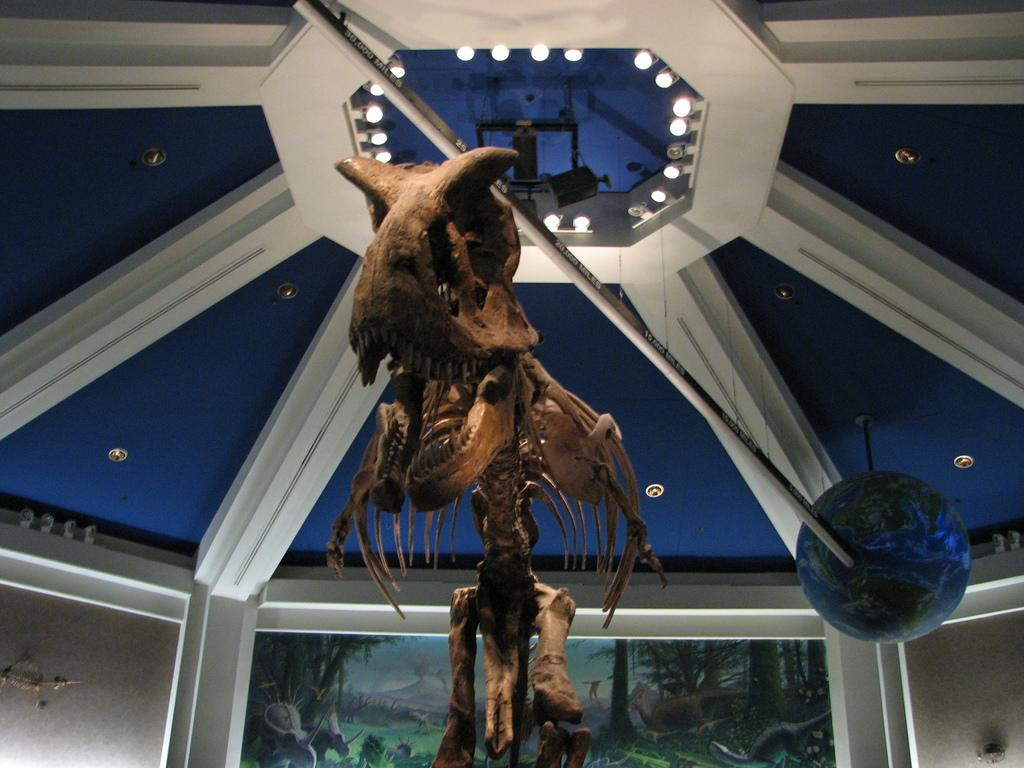What is the main subject of the image? There is a skeleton in the image. What can be seen on the wall in the image? There is a painting on the wall in the image. What is providing illumination in the image? There are lights visible in the image. What type of iron is being used by the grandfather in the image? There is no grandfather or iron present in the image; it only features a skeleton and a painting on the wall. 